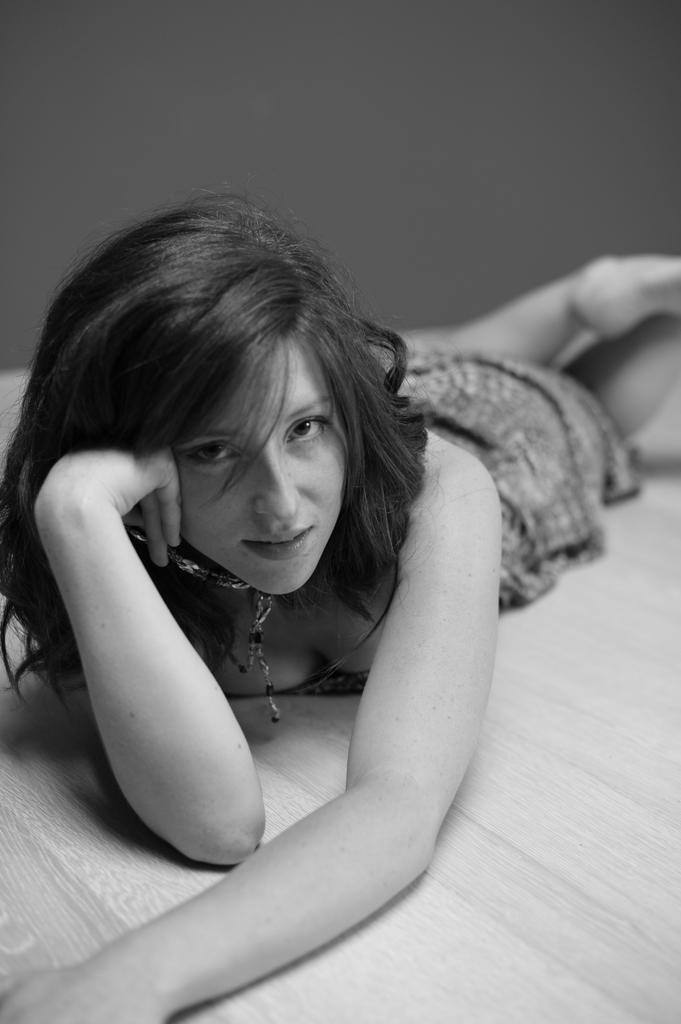Describe this image in one or two sentences. This is a black and white image. In the image there is a lady lying on the surface. 